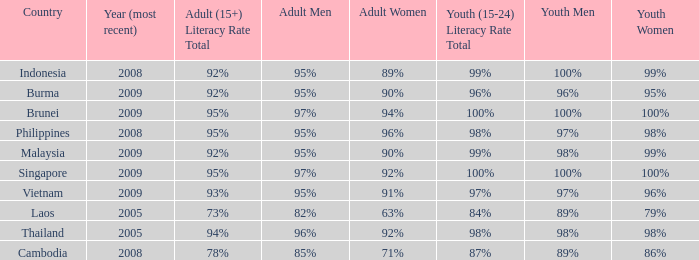What country has a Youth (15-24) Literacy Rate Total of 99%, and a Youth Men of 98%? Malaysia. 